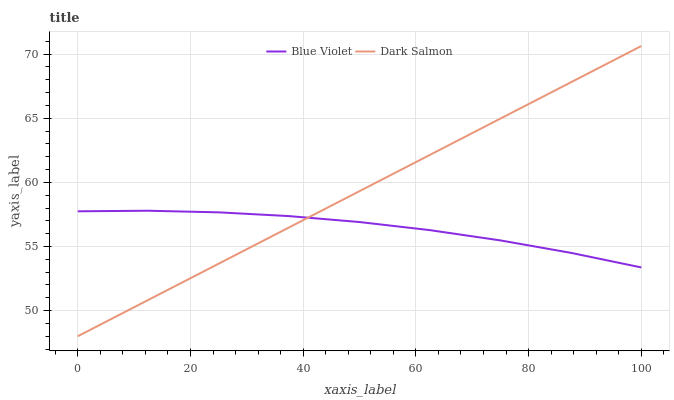Does Blue Violet have the maximum area under the curve?
Answer yes or no. No. Is Blue Violet the smoothest?
Answer yes or no. No. Does Blue Violet have the lowest value?
Answer yes or no. No. Does Blue Violet have the highest value?
Answer yes or no. No. 